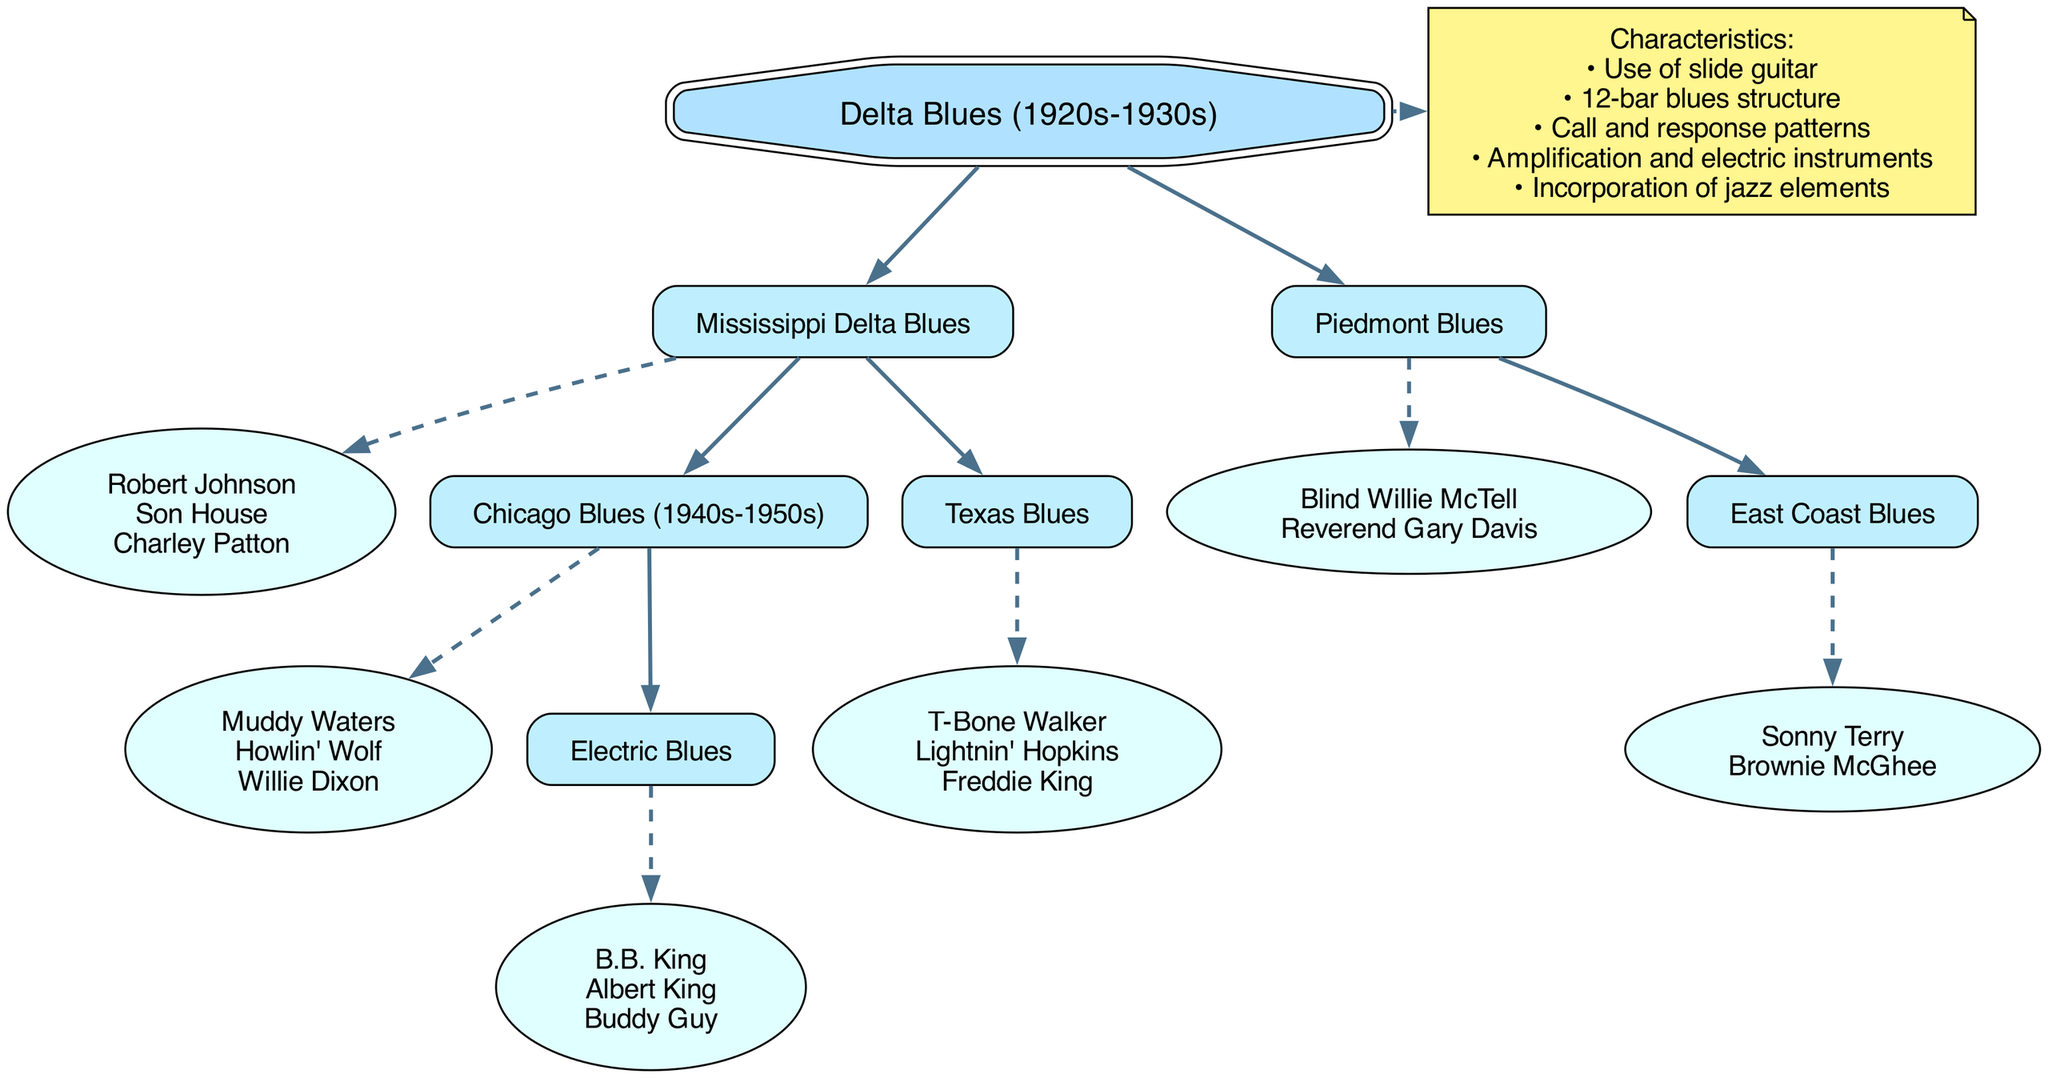What is the root of the family tree? The root node is labeled "Delta Blues (1920s-1930s)," which represents the origin of the family tree structure.
Answer: Delta Blues (1920s-1930s) How many branches are there under the Delta Blues? There are two main branches listed: "Mississippi Delta Blues" and "Piedmont Blues."
Answer: 2 Who are the key artists in Chicago Blues? The artists listed under Chicago Blues are "Muddy Waters," "Howlin' Wolf," and "Willie Dixon."
Answer: Muddy Waters, Howlin' Wolf, Willie Dixon Which genre includes B.B. King? B.B. King is an artist under the "Electric Blues" genre, which is a child of Chicago Blues.
Answer: Electric Blues What characteristics are noted in the diagram? The diagram lists several characteristics, including "Use of slide guitar" and "12-bar blues structure."
Answer: Use of slide guitar, 12-bar blues structure Which genre is a child of Mississippi Delta Blues? The genres listed as children of Mississippi Delta Blues are "Chicago Blues" and "Texas Blues."
Answer: Chicago Blues, Texas Blues What is the relationship between Piedmont Blues and East Coast Blues? East Coast Blues is a child genre of Piedmont Blues, meaning it directly descends from it in the family tree.
Answer: Child genre Name an artist associated with Texas Blues. The artists listed under Texas Blues include "T-Bone Walker," "Lightnin' Hopkins," and "Freddie King."
Answer: T-Bone Walker Which artists are under the genre of East Coast Blues? The artists associated with East Coast Blues are "Sonny Terry" and "Brownie McGhee."
Answer: Sonny Terry, Brownie McGhee 